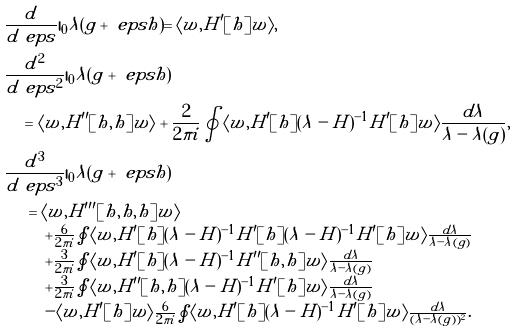Convert formula to latex. <formula><loc_0><loc_0><loc_500><loc_500>& \frac { d } { d \ e p s } | _ { 0 } \lambda ( g + \ e p s h ) = \langle w , H ^ { \prime } [ h ] w \rangle , \\ & \frac { d ^ { 2 } } { d \ e p s ^ { 2 } } | _ { 0 } \lambda ( g + \ e p s h ) \\ & \quad = \langle w , H ^ { \prime \prime } [ h , h ] w \rangle + \frac { 2 } { 2 \pi i } \oint \langle w , H ^ { \prime } [ h ] ( \lambda - H ) ^ { - 1 } H ^ { \prime } [ h ] w \rangle \frac { d \lambda } { \lambda - \lambda ( g ) } , \\ & \frac { d ^ { 3 } } { d \ e p s ^ { 3 } } | _ { 0 } \lambda ( g + \ e p s h ) \\ & \quad \begin{array} { l } = \langle w , H ^ { \prime \prime \prime } [ h , h , h ] w \rangle \\ \quad + \frac { 6 } { 2 \pi i } \oint \langle w , H ^ { \prime } [ h ] ( \lambda - H ) ^ { - 1 } H ^ { \prime } [ h ] ( \lambda - H ) ^ { - 1 } H ^ { \prime } [ h ] w \rangle \frac { d \lambda } { \lambda - \lambda ( g ) } \\ \quad + \frac { 3 } { 2 \pi i } \oint \langle w , H ^ { \prime } [ h ] ( \lambda - H ) ^ { - 1 } H ^ { \prime \prime } [ h , h ] w \rangle \frac { d \lambda } { \lambda - \lambda ( g ) } \\ \quad + \frac { 3 } { 2 \pi i } \oint \langle w , H ^ { \prime \prime } [ h , h ] ( \lambda - H ) ^ { - 1 } H ^ { \prime } [ h ] w \rangle \frac { d \lambda } { \lambda - \lambda ( g ) } \\ \quad - \langle w , H ^ { \prime } [ h ] w \rangle \frac { 6 } { 2 \pi i } \oint \langle w , H ^ { \prime } [ h ] ( \lambda - H ) ^ { - 1 } H ^ { \prime } [ h ] w \rangle \frac { d \lambda } { ( \lambda - \lambda ( g ) ) ^ { 2 } } . \end{array}</formula> 